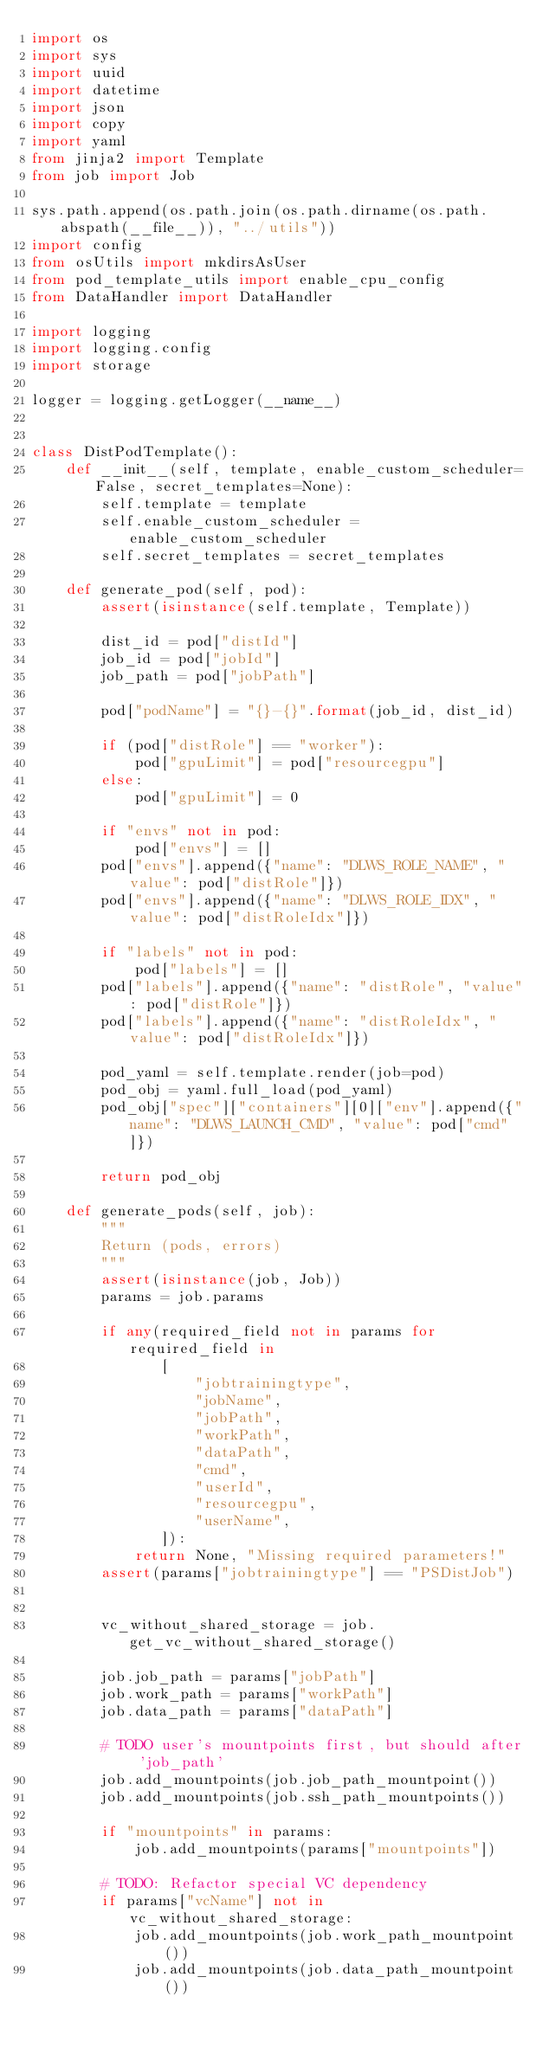<code> <loc_0><loc_0><loc_500><loc_500><_Python_>import os
import sys
import uuid
import datetime
import json
import copy
import yaml
from jinja2 import Template
from job import Job

sys.path.append(os.path.join(os.path.dirname(os.path.abspath(__file__)), "../utils"))
import config
from osUtils import mkdirsAsUser
from pod_template_utils import enable_cpu_config
from DataHandler import DataHandler

import logging
import logging.config
import storage

logger = logging.getLogger(__name__)


class DistPodTemplate():
    def __init__(self, template, enable_custom_scheduler=False, secret_templates=None):
        self.template = template
        self.enable_custom_scheduler = enable_custom_scheduler
        self.secret_templates = secret_templates

    def generate_pod(self, pod):
        assert(isinstance(self.template, Template))

        dist_id = pod["distId"]
        job_id = pod["jobId"]
        job_path = pod["jobPath"]

        pod["podName"] = "{}-{}".format(job_id, dist_id)

        if (pod["distRole"] == "worker"):
            pod["gpuLimit"] = pod["resourcegpu"]
        else:
            pod["gpuLimit"] = 0

        if "envs" not in pod:
            pod["envs"] = []
        pod["envs"].append({"name": "DLWS_ROLE_NAME", "value": pod["distRole"]})
        pod["envs"].append({"name": "DLWS_ROLE_IDX", "value": pod["distRoleIdx"]})

        if "labels" not in pod:
            pod["labels"] = []
        pod["labels"].append({"name": "distRole", "value": pod["distRole"]})
        pod["labels"].append({"name": "distRoleIdx", "value": pod["distRoleIdx"]})

        pod_yaml = self.template.render(job=pod)
        pod_obj = yaml.full_load(pod_yaml)
        pod_obj["spec"]["containers"][0]["env"].append({"name": "DLWS_LAUNCH_CMD", "value": pod["cmd"]})

        return pod_obj

    def generate_pods(self, job):
        """
        Return (pods, errors)
        """
        assert(isinstance(job, Job))
        params = job.params

        if any(required_field not in params for required_field in
               [
                   "jobtrainingtype",
                   "jobName",
                   "jobPath",
                   "workPath",
                   "dataPath",
                   "cmd",
                   "userId",
                   "resourcegpu",
                   "userName",
               ]):
            return None, "Missing required parameters!"
        assert(params["jobtrainingtype"] == "PSDistJob")


        vc_without_shared_storage = job.get_vc_without_shared_storage()

        job.job_path = params["jobPath"]
        job.work_path = params["workPath"]
        job.data_path = params["dataPath"]

        # TODO user's mountpoints first, but should after 'job_path'
        job.add_mountpoints(job.job_path_mountpoint())
        job.add_mountpoints(job.ssh_path_mountpoints())

        if "mountpoints" in params:
            job.add_mountpoints(params["mountpoints"])

        # TODO: Refactor special VC dependency
        if params["vcName"] not in vc_without_shared_storage:
            job.add_mountpoints(job.work_path_mountpoint())
            job.add_mountpoints(job.data_path_mountpoint())</code> 